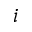Convert formula to latex. <formula><loc_0><loc_0><loc_500><loc_500>i</formula> 